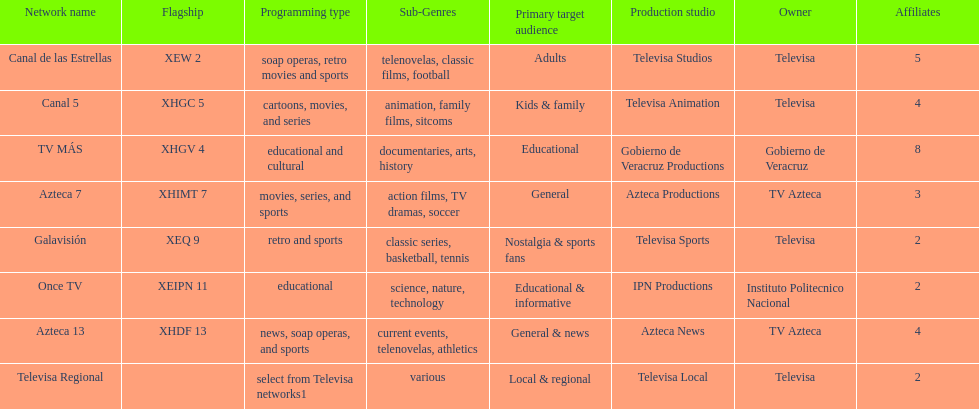Write the full table. {'header': ['Network name', 'Flagship', 'Programming type', 'Sub-Genres', 'Primary target audience', 'Production studio', 'Owner', 'Affiliates'], 'rows': [['Canal de las Estrellas', 'XEW 2', 'soap operas, retro movies and sports', 'telenovelas, classic films, football', 'Adults', 'Televisa Studios', 'Televisa', '5'], ['Canal 5', 'XHGC 5', 'cartoons, movies, and series', 'animation, family films, sitcoms', 'Kids & family', 'Televisa Animation', 'Televisa', '4'], ['TV MÁS', 'XHGV 4', 'educational and cultural', 'documentaries, arts, history', 'Educational', 'Gobierno de Veracruz Productions', 'Gobierno de Veracruz', '8'], ['Azteca 7', 'XHIMT 7', 'movies, series, and sports', 'action films, TV dramas, soccer', 'General', 'Azteca Productions', 'TV Azteca', '3'], ['Galavisión', 'XEQ 9', 'retro and sports', 'classic series, basketball, tennis', 'Nostalgia & sports fans', 'Televisa Sports', 'Televisa', '2'], ['Once TV', 'XEIPN 11', 'educational', 'science, nature, technology', 'Educational & informative', 'IPN Productions', 'Instituto Politecnico Nacional', '2'], ['Azteca 13', 'XHDF 13', 'news, soap operas, and sports', 'current events, telenovelas, athletics', 'General & news', 'Azteca News', 'TV Azteca', '4'], ['Televisa Regional', '', 'select from Televisa networks1', 'various', 'Local & regional', 'Televisa Local', 'Televisa', '2']]} Name each of tv azteca's network names. Azteca 7, Azteca 13. 